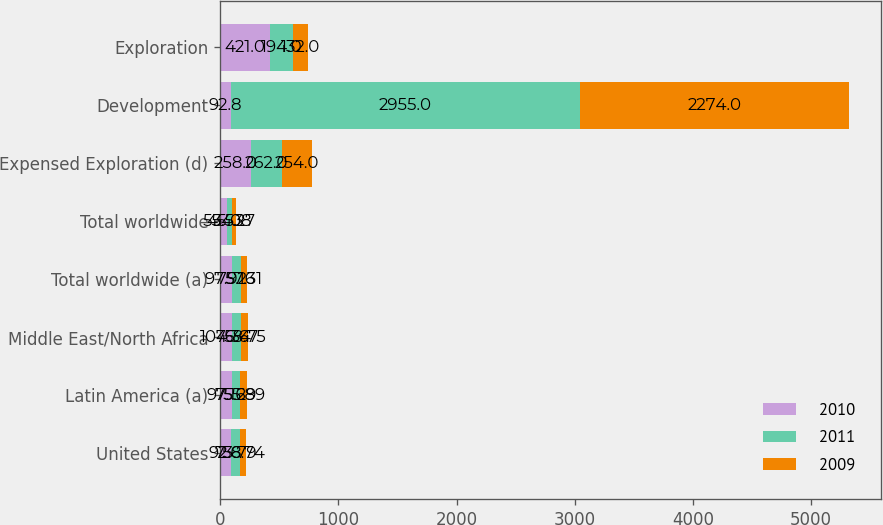Convert chart. <chart><loc_0><loc_0><loc_500><loc_500><stacked_bar_chart><ecel><fcel>United States<fcel>Latin America (a)<fcel>Middle East/North Africa<fcel>Total worldwide (a)<fcel>Total worldwide<fcel>Expensed Exploration (d)<fcel>Development<fcel>Exploration<nl><fcel>2010<fcel>92.8<fcel>97.16<fcel>104.34<fcel>97.92<fcel>55.53<fcel>258<fcel>92.8<fcel>421<nl><fcel>2011<fcel>73.79<fcel>75.29<fcel>76.67<fcel>75.16<fcel>45.08<fcel>262<fcel>2955<fcel>194<nl><fcel>2009<fcel>56.74<fcel>55.89<fcel>58.75<fcel>57.31<fcel>34.27<fcel>254<fcel>2274<fcel>132<nl></chart> 